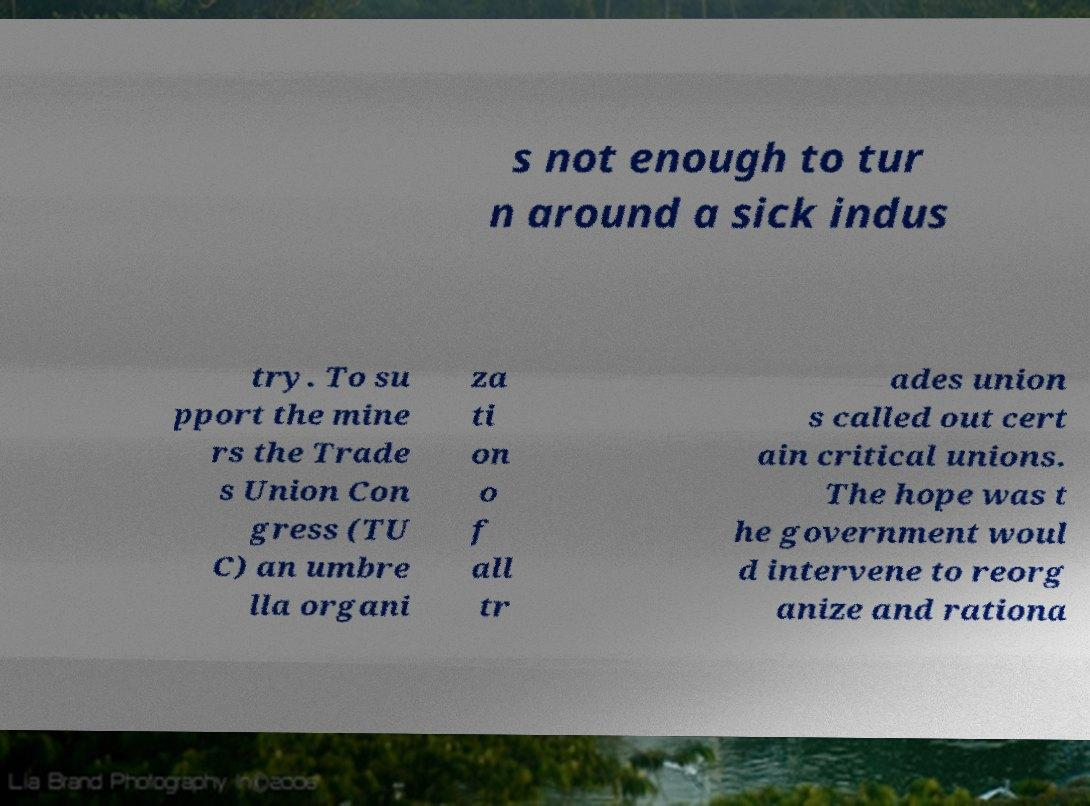What messages or text are displayed in this image? I need them in a readable, typed format. s not enough to tur n around a sick indus try. To su pport the mine rs the Trade s Union Con gress (TU C) an umbre lla organi za ti on o f all tr ades union s called out cert ain critical unions. The hope was t he government woul d intervene to reorg anize and rationa 